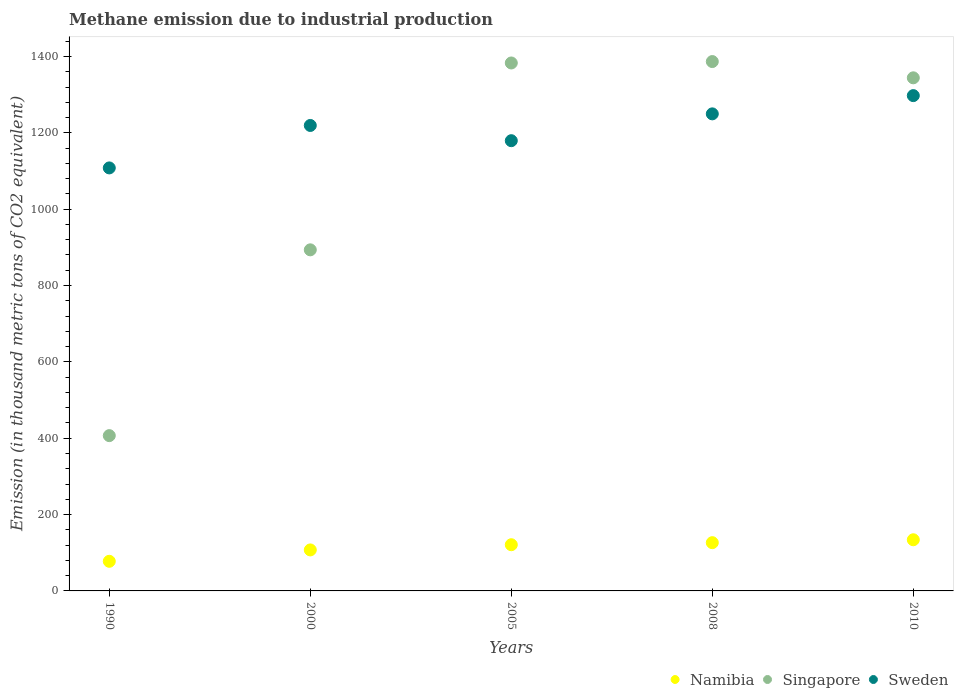How many different coloured dotlines are there?
Your answer should be compact. 3. Is the number of dotlines equal to the number of legend labels?
Your answer should be very brief. Yes. What is the amount of methane emitted in Namibia in 2000?
Offer a terse response. 107.4. Across all years, what is the maximum amount of methane emitted in Sweden?
Ensure brevity in your answer.  1297.5. Across all years, what is the minimum amount of methane emitted in Singapore?
Keep it short and to the point. 406.8. In which year was the amount of methane emitted in Sweden maximum?
Offer a very short reply. 2010. In which year was the amount of methane emitted in Sweden minimum?
Your answer should be very brief. 1990. What is the total amount of methane emitted in Singapore in the graph?
Offer a very short reply. 5414.1. What is the difference between the amount of methane emitted in Namibia in 2005 and that in 2008?
Your response must be concise. -5.4. What is the difference between the amount of methane emitted in Namibia in 2005 and the amount of methane emitted in Sweden in 2000?
Make the answer very short. -1098.3. What is the average amount of methane emitted in Namibia per year?
Give a very brief answer. 113.28. In the year 1990, what is the difference between the amount of methane emitted in Namibia and amount of methane emitted in Sweden?
Provide a succinct answer. -1030.5. What is the ratio of the amount of methane emitted in Namibia in 2005 to that in 2010?
Provide a succinct answer. 0.9. Is the amount of methane emitted in Namibia in 2005 less than that in 2010?
Your answer should be very brief. Yes. Is the difference between the amount of methane emitted in Namibia in 2008 and 2010 greater than the difference between the amount of methane emitted in Sweden in 2008 and 2010?
Provide a short and direct response. Yes. What is the difference between the highest and the second highest amount of methane emitted in Singapore?
Offer a terse response. 3.7. What is the difference between the highest and the lowest amount of methane emitted in Singapore?
Your response must be concise. 979.9. Is the sum of the amount of methane emitted in Sweden in 2000 and 2010 greater than the maximum amount of methane emitted in Singapore across all years?
Give a very brief answer. Yes. How many dotlines are there?
Your response must be concise. 3. How many legend labels are there?
Provide a short and direct response. 3. What is the title of the graph?
Keep it short and to the point. Methane emission due to industrial production. What is the label or title of the Y-axis?
Your response must be concise. Emission (in thousand metric tons of CO2 equivalent). What is the Emission (in thousand metric tons of CO2 equivalent) in Namibia in 1990?
Ensure brevity in your answer.  77.6. What is the Emission (in thousand metric tons of CO2 equivalent) of Singapore in 1990?
Your response must be concise. 406.8. What is the Emission (in thousand metric tons of CO2 equivalent) of Sweden in 1990?
Your response must be concise. 1108.1. What is the Emission (in thousand metric tons of CO2 equivalent) of Namibia in 2000?
Your answer should be compact. 107.4. What is the Emission (in thousand metric tons of CO2 equivalent) of Singapore in 2000?
Give a very brief answer. 893.5. What is the Emission (in thousand metric tons of CO2 equivalent) of Sweden in 2000?
Provide a short and direct response. 1219.3. What is the Emission (in thousand metric tons of CO2 equivalent) in Namibia in 2005?
Offer a very short reply. 121. What is the Emission (in thousand metric tons of CO2 equivalent) in Singapore in 2005?
Give a very brief answer. 1383. What is the Emission (in thousand metric tons of CO2 equivalent) of Sweden in 2005?
Provide a short and direct response. 1179.4. What is the Emission (in thousand metric tons of CO2 equivalent) in Namibia in 2008?
Your response must be concise. 126.4. What is the Emission (in thousand metric tons of CO2 equivalent) in Singapore in 2008?
Give a very brief answer. 1386.7. What is the Emission (in thousand metric tons of CO2 equivalent) in Sweden in 2008?
Provide a succinct answer. 1249.7. What is the Emission (in thousand metric tons of CO2 equivalent) of Namibia in 2010?
Make the answer very short. 134. What is the Emission (in thousand metric tons of CO2 equivalent) in Singapore in 2010?
Your response must be concise. 1344.1. What is the Emission (in thousand metric tons of CO2 equivalent) of Sweden in 2010?
Your response must be concise. 1297.5. Across all years, what is the maximum Emission (in thousand metric tons of CO2 equivalent) of Namibia?
Offer a terse response. 134. Across all years, what is the maximum Emission (in thousand metric tons of CO2 equivalent) in Singapore?
Your answer should be compact. 1386.7. Across all years, what is the maximum Emission (in thousand metric tons of CO2 equivalent) in Sweden?
Give a very brief answer. 1297.5. Across all years, what is the minimum Emission (in thousand metric tons of CO2 equivalent) of Namibia?
Give a very brief answer. 77.6. Across all years, what is the minimum Emission (in thousand metric tons of CO2 equivalent) in Singapore?
Give a very brief answer. 406.8. Across all years, what is the minimum Emission (in thousand metric tons of CO2 equivalent) of Sweden?
Provide a succinct answer. 1108.1. What is the total Emission (in thousand metric tons of CO2 equivalent) of Namibia in the graph?
Keep it short and to the point. 566.4. What is the total Emission (in thousand metric tons of CO2 equivalent) in Singapore in the graph?
Provide a succinct answer. 5414.1. What is the total Emission (in thousand metric tons of CO2 equivalent) of Sweden in the graph?
Your response must be concise. 6054. What is the difference between the Emission (in thousand metric tons of CO2 equivalent) of Namibia in 1990 and that in 2000?
Give a very brief answer. -29.8. What is the difference between the Emission (in thousand metric tons of CO2 equivalent) in Singapore in 1990 and that in 2000?
Your response must be concise. -486.7. What is the difference between the Emission (in thousand metric tons of CO2 equivalent) in Sweden in 1990 and that in 2000?
Make the answer very short. -111.2. What is the difference between the Emission (in thousand metric tons of CO2 equivalent) of Namibia in 1990 and that in 2005?
Ensure brevity in your answer.  -43.4. What is the difference between the Emission (in thousand metric tons of CO2 equivalent) of Singapore in 1990 and that in 2005?
Your response must be concise. -976.2. What is the difference between the Emission (in thousand metric tons of CO2 equivalent) in Sweden in 1990 and that in 2005?
Ensure brevity in your answer.  -71.3. What is the difference between the Emission (in thousand metric tons of CO2 equivalent) in Namibia in 1990 and that in 2008?
Your answer should be very brief. -48.8. What is the difference between the Emission (in thousand metric tons of CO2 equivalent) of Singapore in 1990 and that in 2008?
Make the answer very short. -979.9. What is the difference between the Emission (in thousand metric tons of CO2 equivalent) in Sweden in 1990 and that in 2008?
Provide a short and direct response. -141.6. What is the difference between the Emission (in thousand metric tons of CO2 equivalent) of Namibia in 1990 and that in 2010?
Your response must be concise. -56.4. What is the difference between the Emission (in thousand metric tons of CO2 equivalent) in Singapore in 1990 and that in 2010?
Your response must be concise. -937.3. What is the difference between the Emission (in thousand metric tons of CO2 equivalent) of Sweden in 1990 and that in 2010?
Ensure brevity in your answer.  -189.4. What is the difference between the Emission (in thousand metric tons of CO2 equivalent) in Singapore in 2000 and that in 2005?
Provide a short and direct response. -489.5. What is the difference between the Emission (in thousand metric tons of CO2 equivalent) in Sweden in 2000 and that in 2005?
Your answer should be very brief. 39.9. What is the difference between the Emission (in thousand metric tons of CO2 equivalent) in Singapore in 2000 and that in 2008?
Provide a succinct answer. -493.2. What is the difference between the Emission (in thousand metric tons of CO2 equivalent) in Sweden in 2000 and that in 2008?
Keep it short and to the point. -30.4. What is the difference between the Emission (in thousand metric tons of CO2 equivalent) in Namibia in 2000 and that in 2010?
Make the answer very short. -26.6. What is the difference between the Emission (in thousand metric tons of CO2 equivalent) of Singapore in 2000 and that in 2010?
Offer a terse response. -450.6. What is the difference between the Emission (in thousand metric tons of CO2 equivalent) in Sweden in 2000 and that in 2010?
Your answer should be very brief. -78.2. What is the difference between the Emission (in thousand metric tons of CO2 equivalent) in Singapore in 2005 and that in 2008?
Provide a short and direct response. -3.7. What is the difference between the Emission (in thousand metric tons of CO2 equivalent) of Sweden in 2005 and that in 2008?
Your answer should be very brief. -70.3. What is the difference between the Emission (in thousand metric tons of CO2 equivalent) in Singapore in 2005 and that in 2010?
Your answer should be very brief. 38.9. What is the difference between the Emission (in thousand metric tons of CO2 equivalent) in Sweden in 2005 and that in 2010?
Your response must be concise. -118.1. What is the difference between the Emission (in thousand metric tons of CO2 equivalent) of Namibia in 2008 and that in 2010?
Offer a terse response. -7.6. What is the difference between the Emission (in thousand metric tons of CO2 equivalent) of Singapore in 2008 and that in 2010?
Provide a succinct answer. 42.6. What is the difference between the Emission (in thousand metric tons of CO2 equivalent) of Sweden in 2008 and that in 2010?
Provide a short and direct response. -47.8. What is the difference between the Emission (in thousand metric tons of CO2 equivalent) of Namibia in 1990 and the Emission (in thousand metric tons of CO2 equivalent) of Singapore in 2000?
Provide a succinct answer. -815.9. What is the difference between the Emission (in thousand metric tons of CO2 equivalent) of Namibia in 1990 and the Emission (in thousand metric tons of CO2 equivalent) of Sweden in 2000?
Provide a short and direct response. -1141.7. What is the difference between the Emission (in thousand metric tons of CO2 equivalent) of Singapore in 1990 and the Emission (in thousand metric tons of CO2 equivalent) of Sweden in 2000?
Your response must be concise. -812.5. What is the difference between the Emission (in thousand metric tons of CO2 equivalent) in Namibia in 1990 and the Emission (in thousand metric tons of CO2 equivalent) in Singapore in 2005?
Your answer should be very brief. -1305.4. What is the difference between the Emission (in thousand metric tons of CO2 equivalent) of Namibia in 1990 and the Emission (in thousand metric tons of CO2 equivalent) of Sweden in 2005?
Keep it short and to the point. -1101.8. What is the difference between the Emission (in thousand metric tons of CO2 equivalent) in Singapore in 1990 and the Emission (in thousand metric tons of CO2 equivalent) in Sweden in 2005?
Keep it short and to the point. -772.6. What is the difference between the Emission (in thousand metric tons of CO2 equivalent) of Namibia in 1990 and the Emission (in thousand metric tons of CO2 equivalent) of Singapore in 2008?
Your response must be concise. -1309.1. What is the difference between the Emission (in thousand metric tons of CO2 equivalent) of Namibia in 1990 and the Emission (in thousand metric tons of CO2 equivalent) of Sweden in 2008?
Provide a succinct answer. -1172.1. What is the difference between the Emission (in thousand metric tons of CO2 equivalent) of Singapore in 1990 and the Emission (in thousand metric tons of CO2 equivalent) of Sweden in 2008?
Offer a terse response. -842.9. What is the difference between the Emission (in thousand metric tons of CO2 equivalent) of Namibia in 1990 and the Emission (in thousand metric tons of CO2 equivalent) of Singapore in 2010?
Make the answer very short. -1266.5. What is the difference between the Emission (in thousand metric tons of CO2 equivalent) in Namibia in 1990 and the Emission (in thousand metric tons of CO2 equivalent) in Sweden in 2010?
Give a very brief answer. -1219.9. What is the difference between the Emission (in thousand metric tons of CO2 equivalent) of Singapore in 1990 and the Emission (in thousand metric tons of CO2 equivalent) of Sweden in 2010?
Your answer should be very brief. -890.7. What is the difference between the Emission (in thousand metric tons of CO2 equivalent) in Namibia in 2000 and the Emission (in thousand metric tons of CO2 equivalent) in Singapore in 2005?
Make the answer very short. -1275.6. What is the difference between the Emission (in thousand metric tons of CO2 equivalent) of Namibia in 2000 and the Emission (in thousand metric tons of CO2 equivalent) of Sweden in 2005?
Offer a terse response. -1072. What is the difference between the Emission (in thousand metric tons of CO2 equivalent) in Singapore in 2000 and the Emission (in thousand metric tons of CO2 equivalent) in Sweden in 2005?
Your answer should be compact. -285.9. What is the difference between the Emission (in thousand metric tons of CO2 equivalent) in Namibia in 2000 and the Emission (in thousand metric tons of CO2 equivalent) in Singapore in 2008?
Provide a succinct answer. -1279.3. What is the difference between the Emission (in thousand metric tons of CO2 equivalent) of Namibia in 2000 and the Emission (in thousand metric tons of CO2 equivalent) of Sweden in 2008?
Your answer should be compact. -1142.3. What is the difference between the Emission (in thousand metric tons of CO2 equivalent) of Singapore in 2000 and the Emission (in thousand metric tons of CO2 equivalent) of Sweden in 2008?
Keep it short and to the point. -356.2. What is the difference between the Emission (in thousand metric tons of CO2 equivalent) of Namibia in 2000 and the Emission (in thousand metric tons of CO2 equivalent) of Singapore in 2010?
Make the answer very short. -1236.7. What is the difference between the Emission (in thousand metric tons of CO2 equivalent) in Namibia in 2000 and the Emission (in thousand metric tons of CO2 equivalent) in Sweden in 2010?
Give a very brief answer. -1190.1. What is the difference between the Emission (in thousand metric tons of CO2 equivalent) of Singapore in 2000 and the Emission (in thousand metric tons of CO2 equivalent) of Sweden in 2010?
Make the answer very short. -404. What is the difference between the Emission (in thousand metric tons of CO2 equivalent) in Namibia in 2005 and the Emission (in thousand metric tons of CO2 equivalent) in Singapore in 2008?
Make the answer very short. -1265.7. What is the difference between the Emission (in thousand metric tons of CO2 equivalent) in Namibia in 2005 and the Emission (in thousand metric tons of CO2 equivalent) in Sweden in 2008?
Your answer should be compact. -1128.7. What is the difference between the Emission (in thousand metric tons of CO2 equivalent) in Singapore in 2005 and the Emission (in thousand metric tons of CO2 equivalent) in Sweden in 2008?
Ensure brevity in your answer.  133.3. What is the difference between the Emission (in thousand metric tons of CO2 equivalent) of Namibia in 2005 and the Emission (in thousand metric tons of CO2 equivalent) of Singapore in 2010?
Ensure brevity in your answer.  -1223.1. What is the difference between the Emission (in thousand metric tons of CO2 equivalent) in Namibia in 2005 and the Emission (in thousand metric tons of CO2 equivalent) in Sweden in 2010?
Your response must be concise. -1176.5. What is the difference between the Emission (in thousand metric tons of CO2 equivalent) in Singapore in 2005 and the Emission (in thousand metric tons of CO2 equivalent) in Sweden in 2010?
Your answer should be very brief. 85.5. What is the difference between the Emission (in thousand metric tons of CO2 equivalent) in Namibia in 2008 and the Emission (in thousand metric tons of CO2 equivalent) in Singapore in 2010?
Offer a very short reply. -1217.7. What is the difference between the Emission (in thousand metric tons of CO2 equivalent) in Namibia in 2008 and the Emission (in thousand metric tons of CO2 equivalent) in Sweden in 2010?
Give a very brief answer. -1171.1. What is the difference between the Emission (in thousand metric tons of CO2 equivalent) in Singapore in 2008 and the Emission (in thousand metric tons of CO2 equivalent) in Sweden in 2010?
Provide a short and direct response. 89.2. What is the average Emission (in thousand metric tons of CO2 equivalent) of Namibia per year?
Offer a terse response. 113.28. What is the average Emission (in thousand metric tons of CO2 equivalent) of Singapore per year?
Your response must be concise. 1082.82. What is the average Emission (in thousand metric tons of CO2 equivalent) in Sweden per year?
Provide a succinct answer. 1210.8. In the year 1990, what is the difference between the Emission (in thousand metric tons of CO2 equivalent) of Namibia and Emission (in thousand metric tons of CO2 equivalent) of Singapore?
Give a very brief answer. -329.2. In the year 1990, what is the difference between the Emission (in thousand metric tons of CO2 equivalent) in Namibia and Emission (in thousand metric tons of CO2 equivalent) in Sweden?
Offer a very short reply. -1030.5. In the year 1990, what is the difference between the Emission (in thousand metric tons of CO2 equivalent) of Singapore and Emission (in thousand metric tons of CO2 equivalent) of Sweden?
Your answer should be compact. -701.3. In the year 2000, what is the difference between the Emission (in thousand metric tons of CO2 equivalent) in Namibia and Emission (in thousand metric tons of CO2 equivalent) in Singapore?
Ensure brevity in your answer.  -786.1. In the year 2000, what is the difference between the Emission (in thousand metric tons of CO2 equivalent) in Namibia and Emission (in thousand metric tons of CO2 equivalent) in Sweden?
Your response must be concise. -1111.9. In the year 2000, what is the difference between the Emission (in thousand metric tons of CO2 equivalent) in Singapore and Emission (in thousand metric tons of CO2 equivalent) in Sweden?
Your answer should be compact. -325.8. In the year 2005, what is the difference between the Emission (in thousand metric tons of CO2 equivalent) in Namibia and Emission (in thousand metric tons of CO2 equivalent) in Singapore?
Your response must be concise. -1262. In the year 2005, what is the difference between the Emission (in thousand metric tons of CO2 equivalent) in Namibia and Emission (in thousand metric tons of CO2 equivalent) in Sweden?
Provide a short and direct response. -1058.4. In the year 2005, what is the difference between the Emission (in thousand metric tons of CO2 equivalent) of Singapore and Emission (in thousand metric tons of CO2 equivalent) of Sweden?
Offer a terse response. 203.6. In the year 2008, what is the difference between the Emission (in thousand metric tons of CO2 equivalent) of Namibia and Emission (in thousand metric tons of CO2 equivalent) of Singapore?
Your answer should be compact. -1260.3. In the year 2008, what is the difference between the Emission (in thousand metric tons of CO2 equivalent) in Namibia and Emission (in thousand metric tons of CO2 equivalent) in Sweden?
Provide a succinct answer. -1123.3. In the year 2008, what is the difference between the Emission (in thousand metric tons of CO2 equivalent) of Singapore and Emission (in thousand metric tons of CO2 equivalent) of Sweden?
Your response must be concise. 137. In the year 2010, what is the difference between the Emission (in thousand metric tons of CO2 equivalent) in Namibia and Emission (in thousand metric tons of CO2 equivalent) in Singapore?
Offer a very short reply. -1210.1. In the year 2010, what is the difference between the Emission (in thousand metric tons of CO2 equivalent) of Namibia and Emission (in thousand metric tons of CO2 equivalent) of Sweden?
Your answer should be compact. -1163.5. In the year 2010, what is the difference between the Emission (in thousand metric tons of CO2 equivalent) of Singapore and Emission (in thousand metric tons of CO2 equivalent) of Sweden?
Offer a terse response. 46.6. What is the ratio of the Emission (in thousand metric tons of CO2 equivalent) of Namibia in 1990 to that in 2000?
Your answer should be very brief. 0.72. What is the ratio of the Emission (in thousand metric tons of CO2 equivalent) of Singapore in 1990 to that in 2000?
Give a very brief answer. 0.46. What is the ratio of the Emission (in thousand metric tons of CO2 equivalent) of Sweden in 1990 to that in 2000?
Offer a very short reply. 0.91. What is the ratio of the Emission (in thousand metric tons of CO2 equivalent) of Namibia in 1990 to that in 2005?
Offer a very short reply. 0.64. What is the ratio of the Emission (in thousand metric tons of CO2 equivalent) in Singapore in 1990 to that in 2005?
Offer a terse response. 0.29. What is the ratio of the Emission (in thousand metric tons of CO2 equivalent) in Sweden in 1990 to that in 2005?
Give a very brief answer. 0.94. What is the ratio of the Emission (in thousand metric tons of CO2 equivalent) of Namibia in 1990 to that in 2008?
Provide a succinct answer. 0.61. What is the ratio of the Emission (in thousand metric tons of CO2 equivalent) in Singapore in 1990 to that in 2008?
Your response must be concise. 0.29. What is the ratio of the Emission (in thousand metric tons of CO2 equivalent) of Sweden in 1990 to that in 2008?
Ensure brevity in your answer.  0.89. What is the ratio of the Emission (in thousand metric tons of CO2 equivalent) in Namibia in 1990 to that in 2010?
Give a very brief answer. 0.58. What is the ratio of the Emission (in thousand metric tons of CO2 equivalent) in Singapore in 1990 to that in 2010?
Offer a very short reply. 0.3. What is the ratio of the Emission (in thousand metric tons of CO2 equivalent) in Sweden in 1990 to that in 2010?
Provide a succinct answer. 0.85. What is the ratio of the Emission (in thousand metric tons of CO2 equivalent) in Namibia in 2000 to that in 2005?
Ensure brevity in your answer.  0.89. What is the ratio of the Emission (in thousand metric tons of CO2 equivalent) in Singapore in 2000 to that in 2005?
Ensure brevity in your answer.  0.65. What is the ratio of the Emission (in thousand metric tons of CO2 equivalent) of Sweden in 2000 to that in 2005?
Offer a very short reply. 1.03. What is the ratio of the Emission (in thousand metric tons of CO2 equivalent) in Namibia in 2000 to that in 2008?
Provide a succinct answer. 0.85. What is the ratio of the Emission (in thousand metric tons of CO2 equivalent) in Singapore in 2000 to that in 2008?
Ensure brevity in your answer.  0.64. What is the ratio of the Emission (in thousand metric tons of CO2 equivalent) in Sweden in 2000 to that in 2008?
Make the answer very short. 0.98. What is the ratio of the Emission (in thousand metric tons of CO2 equivalent) of Namibia in 2000 to that in 2010?
Ensure brevity in your answer.  0.8. What is the ratio of the Emission (in thousand metric tons of CO2 equivalent) of Singapore in 2000 to that in 2010?
Your answer should be compact. 0.66. What is the ratio of the Emission (in thousand metric tons of CO2 equivalent) in Sweden in 2000 to that in 2010?
Your answer should be compact. 0.94. What is the ratio of the Emission (in thousand metric tons of CO2 equivalent) of Namibia in 2005 to that in 2008?
Your response must be concise. 0.96. What is the ratio of the Emission (in thousand metric tons of CO2 equivalent) in Sweden in 2005 to that in 2008?
Keep it short and to the point. 0.94. What is the ratio of the Emission (in thousand metric tons of CO2 equivalent) in Namibia in 2005 to that in 2010?
Provide a succinct answer. 0.9. What is the ratio of the Emission (in thousand metric tons of CO2 equivalent) of Singapore in 2005 to that in 2010?
Keep it short and to the point. 1.03. What is the ratio of the Emission (in thousand metric tons of CO2 equivalent) of Sweden in 2005 to that in 2010?
Provide a short and direct response. 0.91. What is the ratio of the Emission (in thousand metric tons of CO2 equivalent) of Namibia in 2008 to that in 2010?
Your response must be concise. 0.94. What is the ratio of the Emission (in thousand metric tons of CO2 equivalent) in Singapore in 2008 to that in 2010?
Offer a very short reply. 1.03. What is the ratio of the Emission (in thousand metric tons of CO2 equivalent) in Sweden in 2008 to that in 2010?
Offer a terse response. 0.96. What is the difference between the highest and the second highest Emission (in thousand metric tons of CO2 equivalent) in Namibia?
Keep it short and to the point. 7.6. What is the difference between the highest and the second highest Emission (in thousand metric tons of CO2 equivalent) in Singapore?
Offer a terse response. 3.7. What is the difference between the highest and the second highest Emission (in thousand metric tons of CO2 equivalent) in Sweden?
Make the answer very short. 47.8. What is the difference between the highest and the lowest Emission (in thousand metric tons of CO2 equivalent) in Namibia?
Your response must be concise. 56.4. What is the difference between the highest and the lowest Emission (in thousand metric tons of CO2 equivalent) of Singapore?
Provide a short and direct response. 979.9. What is the difference between the highest and the lowest Emission (in thousand metric tons of CO2 equivalent) of Sweden?
Your response must be concise. 189.4. 